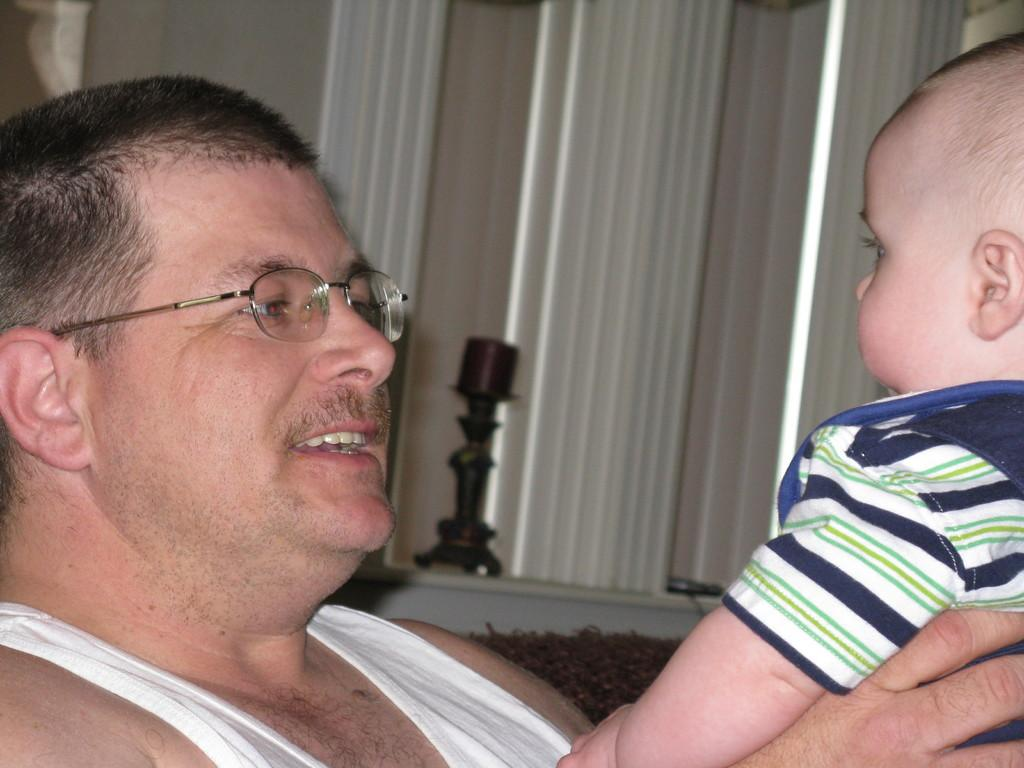What is the main subject of the image? The main subject of the image is a man. What is the man doing in the image? The man is holding a kid in the image. Can you describe the man's appearance? The man is wearing spectacles in the image. What can be seen in the background of the image? There is an unspecified element present in the background of the image. What type of music theory is being discussed by the man and the kid in the image? There is no indication in the image that the man and the kid are discussing music theory, so it cannot be determined from the picture. 